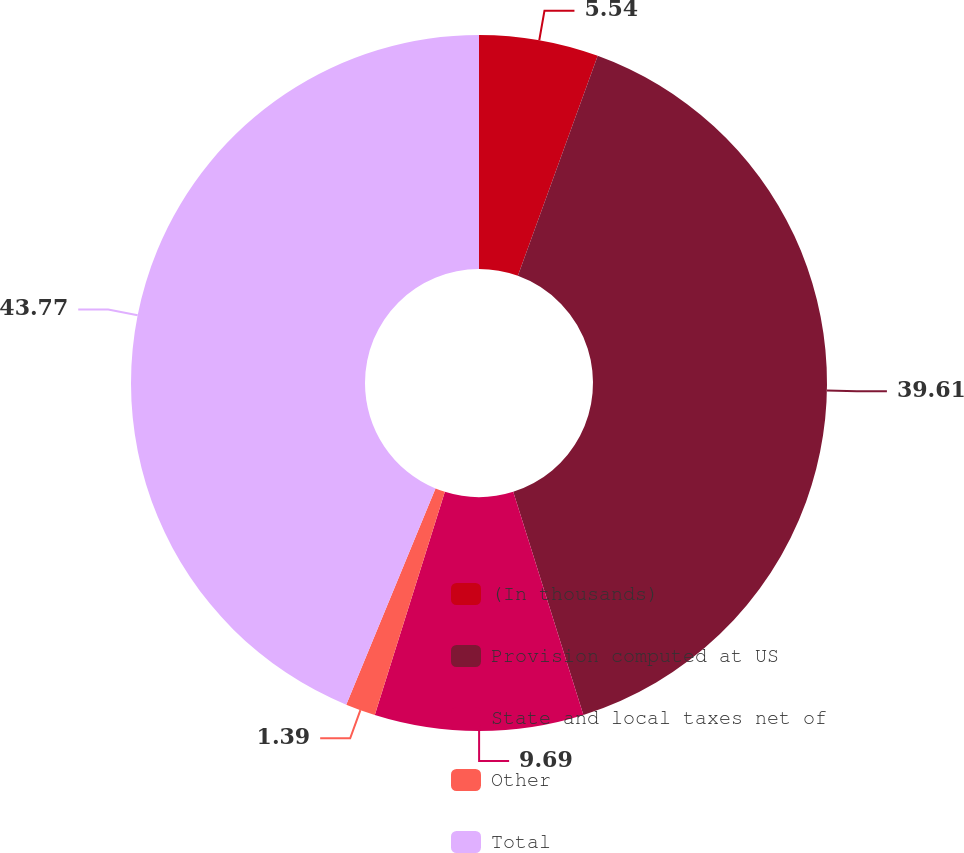Convert chart. <chart><loc_0><loc_0><loc_500><loc_500><pie_chart><fcel>(In thousands)<fcel>Provision computed at US<fcel>State and local taxes net of<fcel>Other<fcel>Total<nl><fcel>5.54%<fcel>39.61%<fcel>9.69%<fcel>1.39%<fcel>43.77%<nl></chart> 